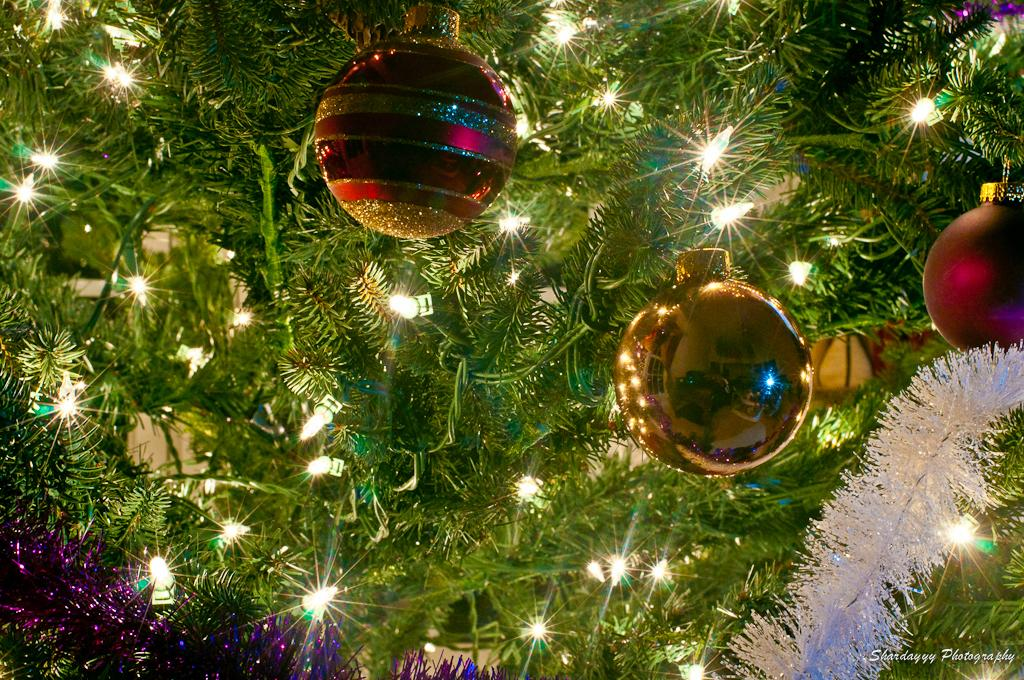What is the main subject of the image? There is a Christmas tree in the center of the image. What can be seen illuminating the tree and other objects in the image? There are lights visible in the image. What other items are present in the image besides the Christmas tree and lights? There are decorative items in the image. Can you see your friend holding a quill in the image? There is no friend or quill present in the image; it features a Christmas tree with lights and decorative items. 